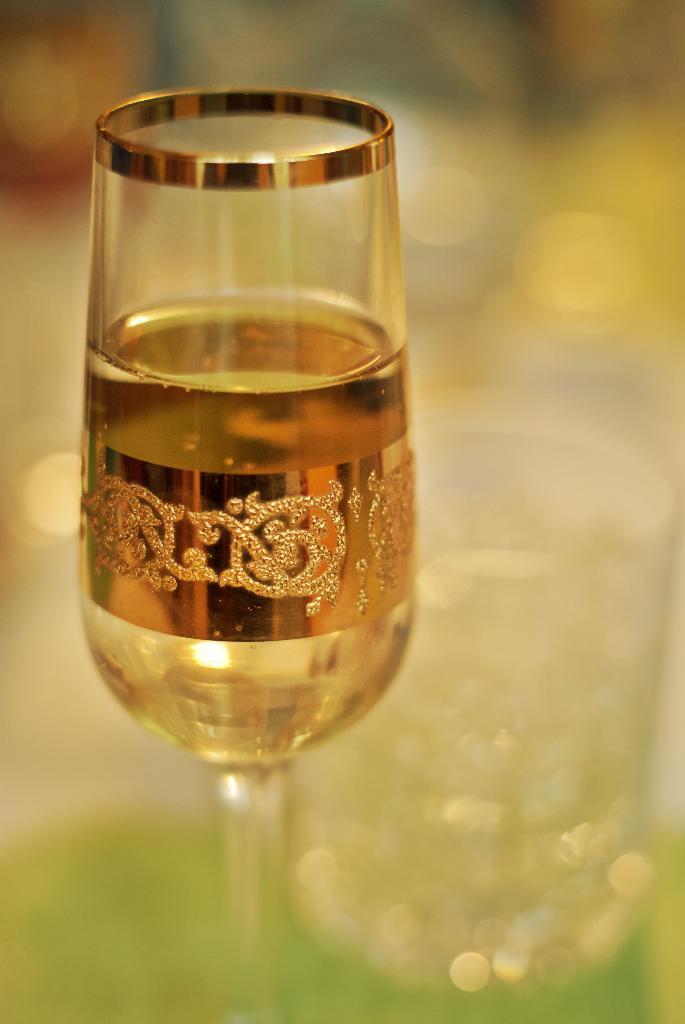Can you describe this image briefly? In this image we can see a glass with some drink on the surface and the background is blurred. 